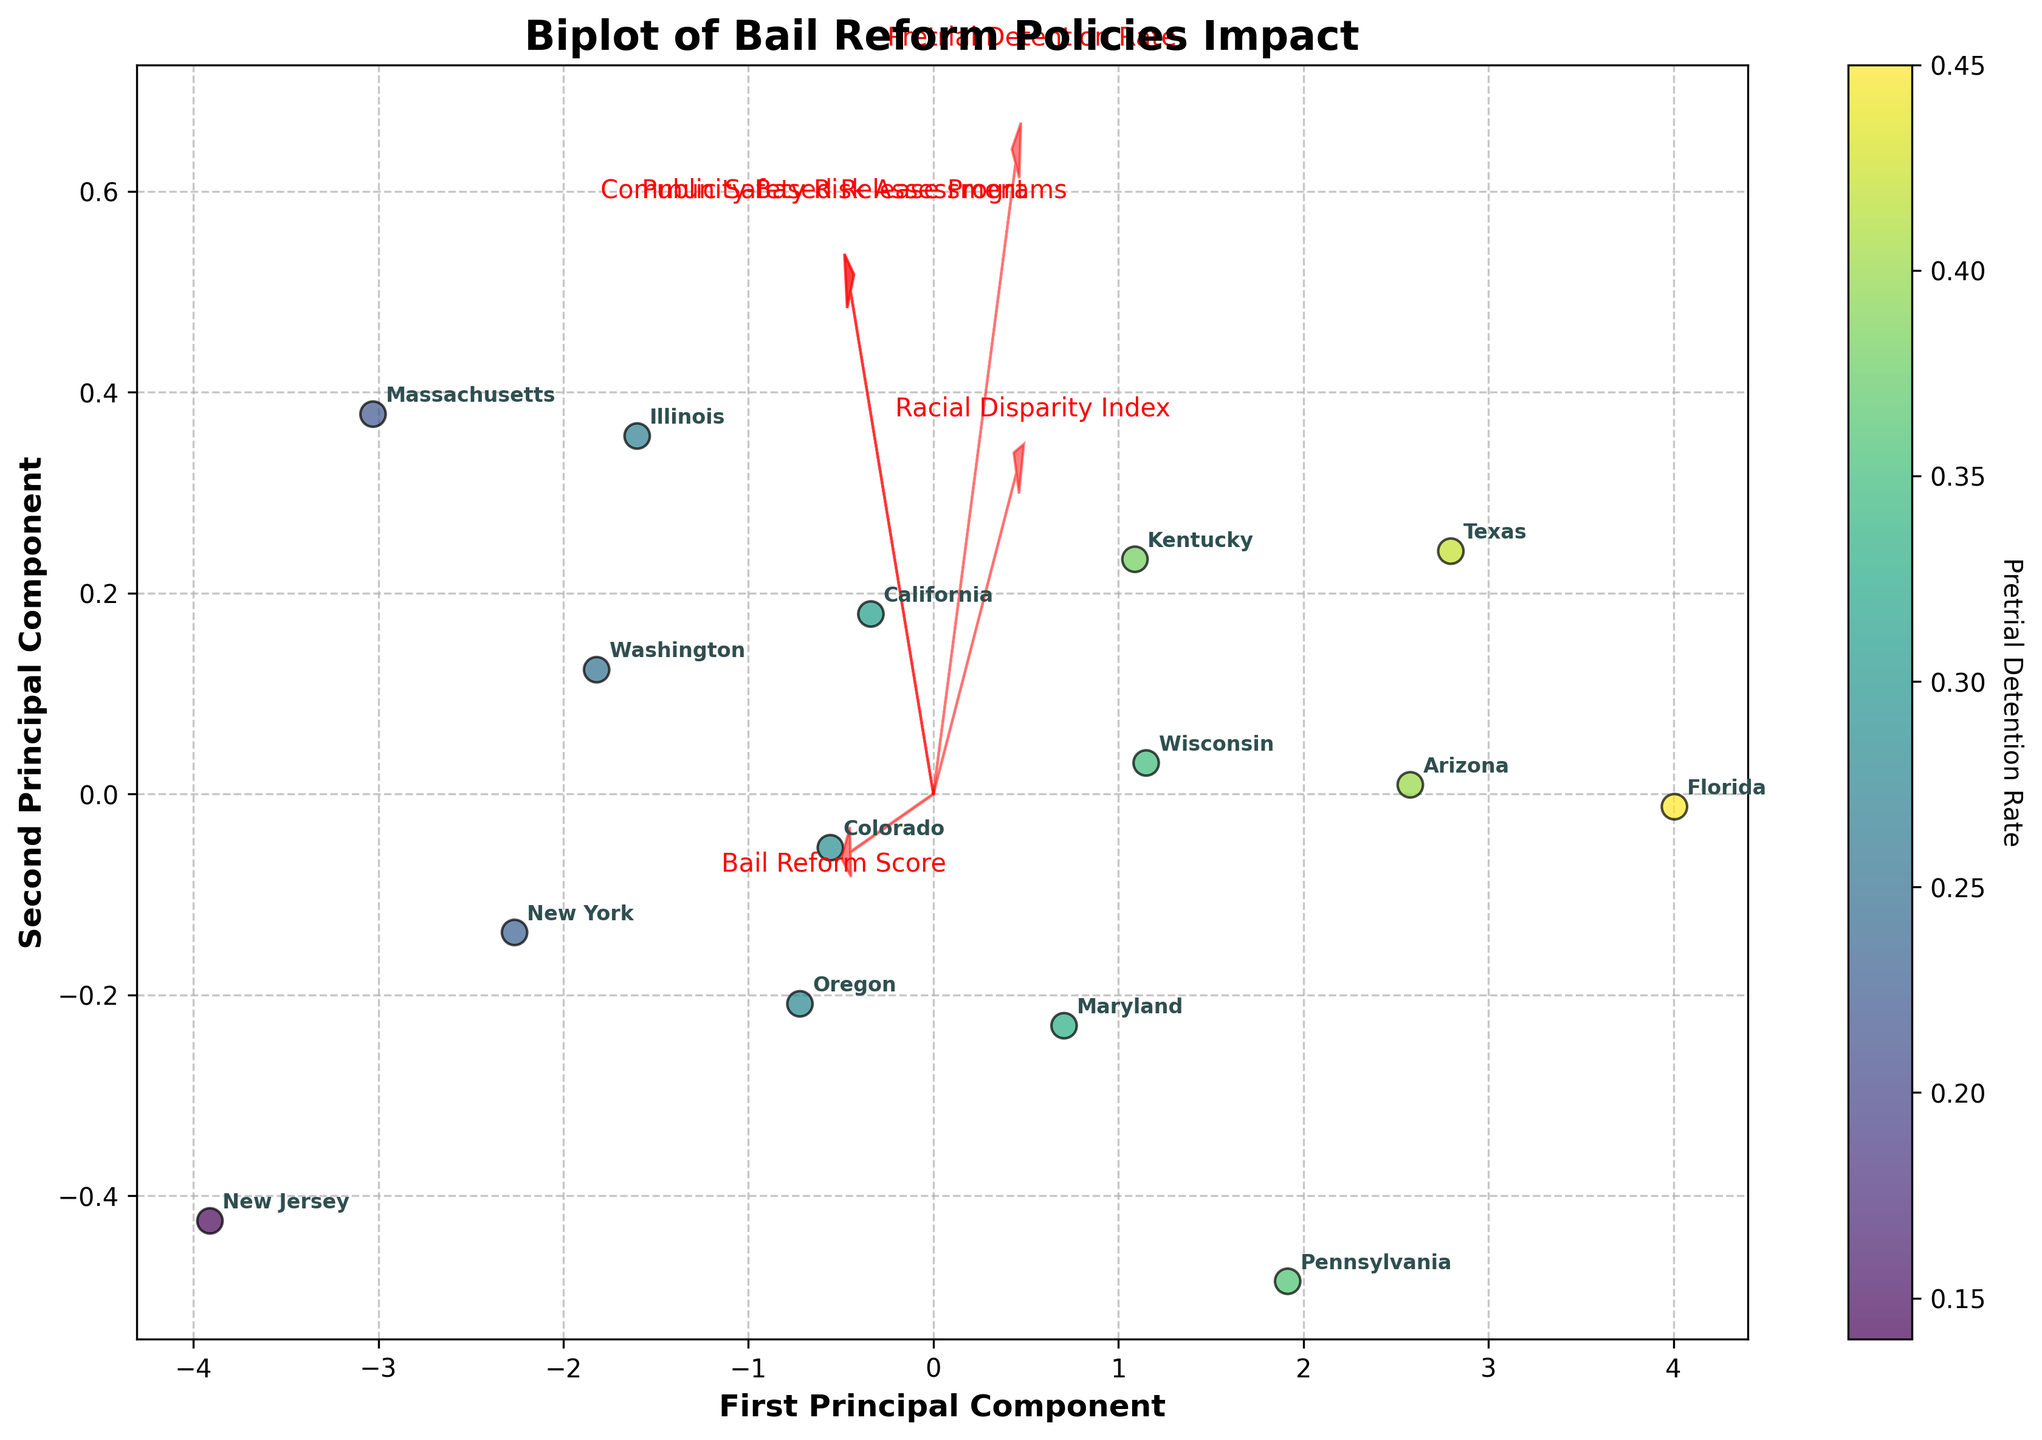What is the title of the plot? The title of the plot is displayed at the top-center of the figure and it reads "Biplot of Bail Reform Policies Impact." This title provides an overview of the data visualization.
Answer: Biplot of Bail Reform Policies Impact Which state has the highest pretrial detention rate? The color intensity of the markers in the scatter plot represents the pretrial detention rate, and the legend on the right helps in identifying the rates. The darkest marker would indicate the highest rate. Florida has the highest pretrial detention rate as it is the darkest.
Answer: Florida What are the axes labels in the plot? The axes labels are indicated at the bottom and left sides of the plot, showing the dimensions of the principal components. The x-axis is labeled "First Principal Component" and the y-axis is labeled "Second Principal Component."
Answer: First Principal Component, Second Principal Component Which state is represented by the point closest to the origin (0,0) on the plot? The origin (0,0) is the center point of the plot. Washington is the closest state to the origin according to the annotations next to the points.
Answer: Washington What do the red arrows in the plot represent? The red arrows represent feature vectors of the specific characteristics analyzed in the plot, including 'Pretrial Detention Rate,' 'Bail Reform Score,' 'Racial Disparity Index,' 'Public Safety Risk Assessment,' and 'Community-Based Release Programs.' The directions and lengths of the arrows indicate the contribution and importance of these features in the principal components.
Answer: Feature vectors Which states have a higher Bail Reform Score than California? The position of California can be identified from the annotations, and states with labels positioned relatively higher along the component associated with the 'Bail Reform Score' arrow have higher scores. New Jersey, New York, Massachusetts, and Washington have higher Bail Reform Scores than California.
Answer: New Jersey, New York, Massachusetts, Washington Describe the overall trend between Pretrial Detention Rate and Bail Reform Score as observed from the plot. By examining the vectors for 'Pretrial Detention Rate' and 'Bail Reform Score,' there seems to be an inverse relationship. States with lower pretrial detention rates tend to have higher bail reform scores, as indicated by the opposing directions of the respective arrows.
Answer: Inverse relationship Which feature vector has the largest influence on the first principal component? The feature vector with the longest arrow in the direction of the first principal component (x-axis) has the largest influence. 'Pretrial Detention Rate' shows the longest arrow in the direction of the x-axis, indicating it has the largest influence.
Answer: Pretrial Detention Rate What can be inferred about New Jersey's position relative to the Bail Reform Score and Pretrial Detention Rate? New Jersey's position is close to the direction of the 'Bail Reform Score' arrow and opposite to the 'Pretrial Detention Rate' arrow, which suggests New Jersey has a high bail reform score and a low pretrial detention rate.
Answer: High Bail Reform Score, Low Pretrial Detention Rate Which states appear to have similar pretrial detention rates based on their positions in the plot? States situated closely together in the plot likely have similar pretrial detention rates. Oregon, Illinois, and Colorado are clustered relatively close to each other, indicating similar pretrial detention rates.
Answer: Oregon, Illinois, Colorado 